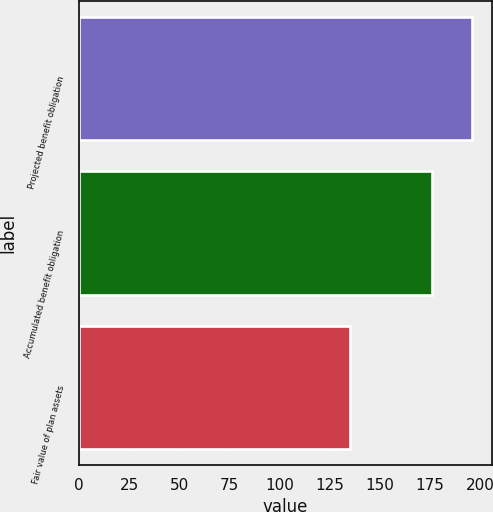Convert chart to OTSL. <chart><loc_0><loc_0><loc_500><loc_500><bar_chart><fcel>Projected benefit obligation<fcel>Accumulated benefit obligation<fcel>Fair value of plan assets<nl><fcel>196<fcel>176<fcel>135<nl></chart> 